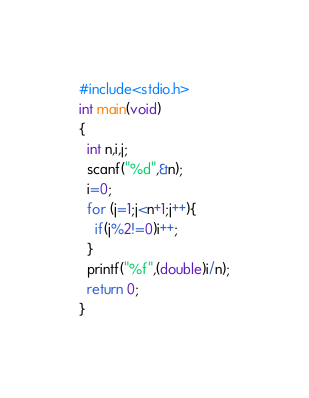<code> <loc_0><loc_0><loc_500><loc_500><_C_>#include<stdio.h>
int main(void)
{
  int n,i,j;
  scanf("%d",&n);
  i=0;
  for (j=1;j<n+1;j++){
    if(j%2!=0)i++;
  }
  printf("%f",(double)i/n);
  return 0;
}</code> 